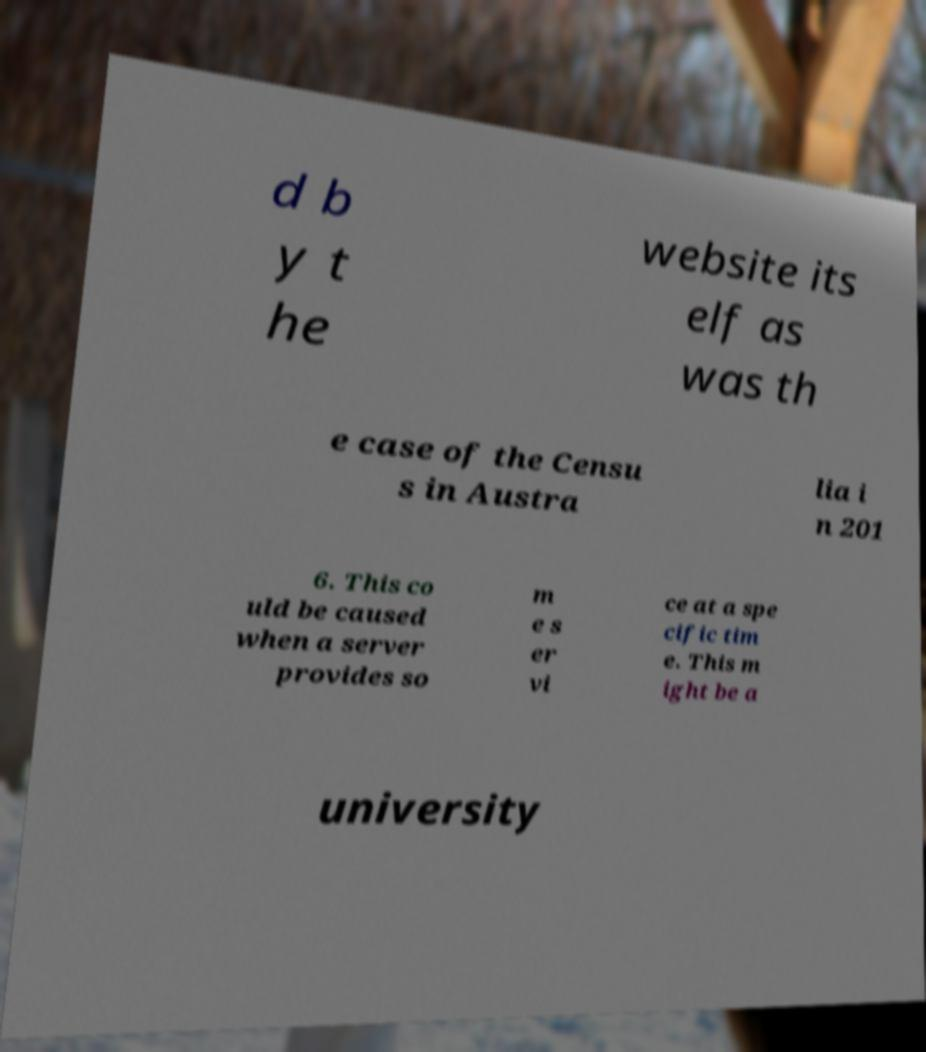Could you assist in decoding the text presented in this image and type it out clearly? d b y t he website its elf as was th e case of the Censu s in Austra lia i n 201 6. This co uld be caused when a server provides so m e s er vi ce at a spe cific tim e. This m ight be a university 